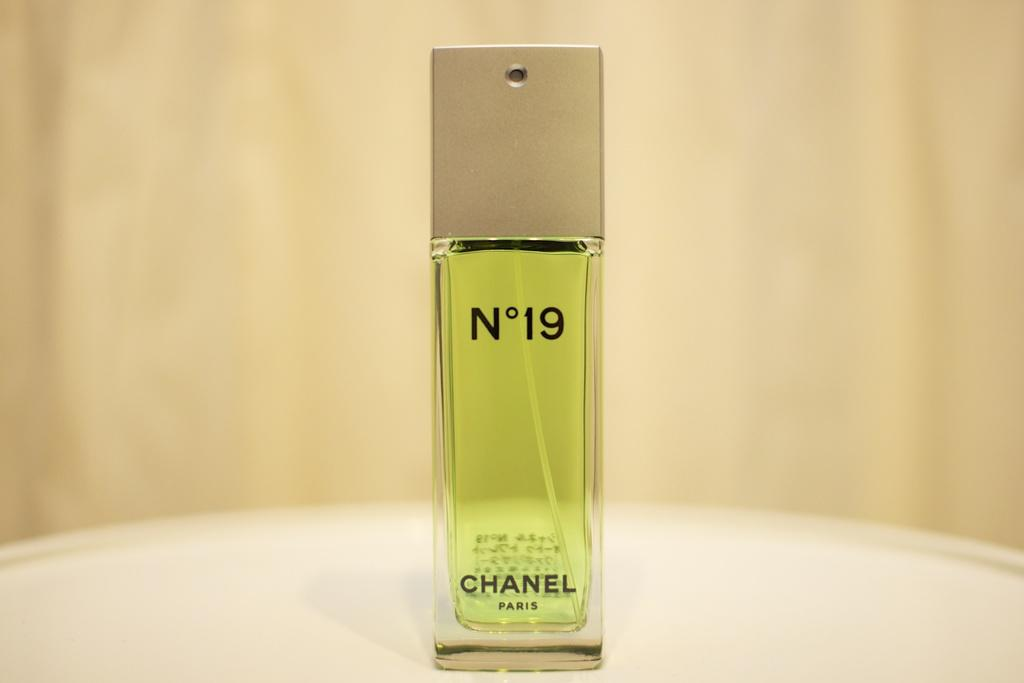Provide a one-sentence caption for the provided image. A perfume bottle of Chanel No 19 on a pedestal. 